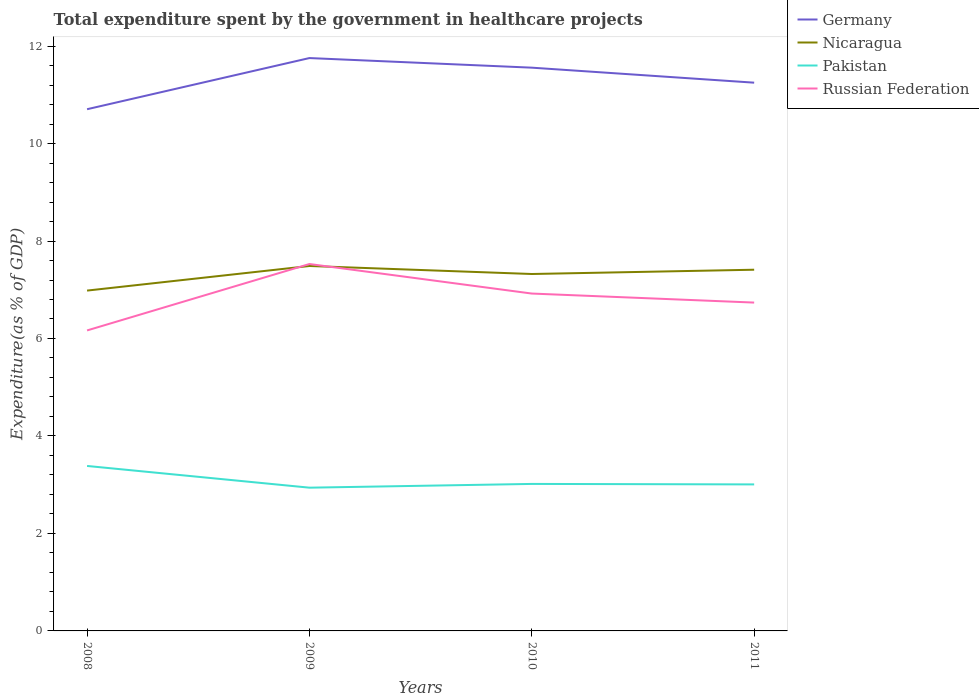Across all years, what is the maximum total expenditure spent by the government in healthcare projects in Germany?
Offer a very short reply. 10.7. What is the total total expenditure spent by the government in healthcare projects in Russian Federation in the graph?
Make the answer very short. -0.57. What is the difference between the highest and the second highest total expenditure spent by the government in healthcare projects in Russian Federation?
Your answer should be very brief. 1.36. How many years are there in the graph?
Ensure brevity in your answer.  4. Does the graph contain any zero values?
Make the answer very short. No. How are the legend labels stacked?
Make the answer very short. Vertical. What is the title of the graph?
Provide a short and direct response. Total expenditure spent by the government in healthcare projects. What is the label or title of the Y-axis?
Your answer should be very brief. Expenditure(as % of GDP). What is the Expenditure(as % of GDP) in Germany in 2008?
Offer a terse response. 10.7. What is the Expenditure(as % of GDP) in Nicaragua in 2008?
Offer a very short reply. 6.98. What is the Expenditure(as % of GDP) of Pakistan in 2008?
Your response must be concise. 3.38. What is the Expenditure(as % of GDP) of Russian Federation in 2008?
Provide a short and direct response. 6.17. What is the Expenditure(as % of GDP) in Germany in 2009?
Ensure brevity in your answer.  11.75. What is the Expenditure(as % of GDP) of Nicaragua in 2009?
Ensure brevity in your answer.  7.49. What is the Expenditure(as % of GDP) of Pakistan in 2009?
Make the answer very short. 2.94. What is the Expenditure(as % of GDP) in Russian Federation in 2009?
Your answer should be very brief. 7.53. What is the Expenditure(as % of GDP) of Germany in 2010?
Ensure brevity in your answer.  11.56. What is the Expenditure(as % of GDP) of Nicaragua in 2010?
Offer a very short reply. 7.32. What is the Expenditure(as % of GDP) of Pakistan in 2010?
Give a very brief answer. 3.02. What is the Expenditure(as % of GDP) of Russian Federation in 2010?
Your answer should be very brief. 6.92. What is the Expenditure(as % of GDP) of Germany in 2011?
Provide a succinct answer. 11.25. What is the Expenditure(as % of GDP) in Nicaragua in 2011?
Offer a very short reply. 7.41. What is the Expenditure(as % of GDP) of Pakistan in 2011?
Give a very brief answer. 3.01. What is the Expenditure(as % of GDP) of Russian Federation in 2011?
Offer a terse response. 6.74. Across all years, what is the maximum Expenditure(as % of GDP) in Germany?
Your response must be concise. 11.75. Across all years, what is the maximum Expenditure(as % of GDP) in Nicaragua?
Give a very brief answer. 7.49. Across all years, what is the maximum Expenditure(as % of GDP) of Pakistan?
Your answer should be very brief. 3.38. Across all years, what is the maximum Expenditure(as % of GDP) of Russian Federation?
Offer a very short reply. 7.53. Across all years, what is the minimum Expenditure(as % of GDP) of Germany?
Your response must be concise. 10.7. Across all years, what is the minimum Expenditure(as % of GDP) of Nicaragua?
Provide a succinct answer. 6.98. Across all years, what is the minimum Expenditure(as % of GDP) in Pakistan?
Give a very brief answer. 2.94. Across all years, what is the minimum Expenditure(as % of GDP) of Russian Federation?
Your answer should be very brief. 6.17. What is the total Expenditure(as % of GDP) of Germany in the graph?
Your answer should be compact. 45.26. What is the total Expenditure(as % of GDP) of Nicaragua in the graph?
Provide a succinct answer. 29.2. What is the total Expenditure(as % of GDP) of Pakistan in the graph?
Your answer should be compact. 12.35. What is the total Expenditure(as % of GDP) of Russian Federation in the graph?
Keep it short and to the point. 27.35. What is the difference between the Expenditure(as % of GDP) of Germany in 2008 and that in 2009?
Provide a short and direct response. -1.05. What is the difference between the Expenditure(as % of GDP) in Nicaragua in 2008 and that in 2009?
Provide a succinct answer. -0.5. What is the difference between the Expenditure(as % of GDP) in Pakistan in 2008 and that in 2009?
Offer a very short reply. 0.45. What is the difference between the Expenditure(as % of GDP) of Russian Federation in 2008 and that in 2009?
Give a very brief answer. -1.36. What is the difference between the Expenditure(as % of GDP) in Germany in 2008 and that in 2010?
Your answer should be very brief. -0.85. What is the difference between the Expenditure(as % of GDP) of Nicaragua in 2008 and that in 2010?
Offer a terse response. -0.34. What is the difference between the Expenditure(as % of GDP) in Pakistan in 2008 and that in 2010?
Offer a terse response. 0.37. What is the difference between the Expenditure(as % of GDP) of Russian Federation in 2008 and that in 2010?
Make the answer very short. -0.76. What is the difference between the Expenditure(as % of GDP) of Germany in 2008 and that in 2011?
Your answer should be very brief. -0.54. What is the difference between the Expenditure(as % of GDP) in Nicaragua in 2008 and that in 2011?
Your response must be concise. -0.43. What is the difference between the Expenditure(as % of GDP) of Pakistan in 2008 and that in 2011?
Ensure brevity in your answer.  0.38. What is the difference between the Expenditure(as % of GDP) in Russian Federation in 2008 and that in 2011?
Provide a succinct answer. -0.57. What is the difference between the Expenditure(as % of GDP) of Germany in 2009 and that in 2010?
Give a very brief answer. 0.2. What is the difference between the Expenditure(as % of GDP) of Nicaragua in 2009 and that in 2010?
Your response must be concise. 0.16. What is the difference between the Expenditure(as % of GDP) in Pakistan in 2009 and that in 2010?
Your response must be concise. -0.08. What is the difference between the Expenditure(as % of GDP) in Russian Federation in 2009 and that in 2010?
Your response must be concise. 0.61. What is the difference between the Expenditure(as % of GDP) of Germany in 2009 and that in 2011?
Your response must be concise. 0.51. What is the difference between the Expenditure(as % of GDP) of Nicaragua in 2009 and that in 2011?
Provide a short and direct response. 0.08. What is the difference between the Expenditure(as % of GDP) of Pakistan in 2009 and that in 2011?
Make the answer very short. -0.07. What is the difference between the Expenditure(as % of GDP) in Russian Federation in 2009 and that in 2011?
Provide a short and direct response. 0.79. What is the difference between the Expenditure(as % of GDP) of Germany in 2010 and that in 2011?
Offer a very short reply. 0.31. What is the difference between the Expenditure(as % of GDP) in Nicaragua in 2010 and that in 2011?
Offer a very short reply. -0.09. What is the difference between the Expenditure(as % of GDP) in Pakistan in 2010 and that in 2011?
Ensure brevity in your answer.  0.01. What is the difference between the Expenditure(as % of GDP) of Russian Federation in 2010 and that in 2011?
Your response must be concise. 0.19. What is the difference between the Expenditure(as % of GDP) in Germany in 2008 and the Expenditure(as % of GDP) in Nicaragua in 2009?
Make the answer very short. 3.22. What is the difference between the Expenditure(as % of GDP) in Germany in 2008 and the Expenditure(as % of GDP) in Pakistan in 2009?
Give a very brief answer. 7.76. What is the difference between the Expenditure(as % of GDP) in Germany in 2008 and the Expenditure(as % of GDP) in Russian Federation in 2009?
Make the answer very short. 3.18. What is the difference between the Expenditure(as % of GDP) of Nicaragua in 2008 and the Expenditure(as % of GDP) of Pakistan in 2009?
Make the answer very short. 4.04. What is the difference between the Expenditure(as % of GDP) of Nicaragua in 2008 and the Expenditure(as % of GDP) of Russian Federation in 2009?
Your response must be concise. -0.55. What is the difference between the Expenditure(as % of GDP) of Pakistan in 2008 and the Expenditure(as % of GDP) of Russian Federation in 2009?
Provide a short and direct response. -4.14. What is the difference between the Expenditure(as % of GDP) of Germany in 2008 and the Expenditure(as % of GDP) of Nicaragua in 2010?
Your answer should be compact. 3.38. What is the difference between the Expenditure(as % of GDP) of Germany in 2008 and the Expenditure(as % of GDP) of Pakistan in 2010?
Offer a very short reply. 7.69. What is the difference between the Expenditure(as % of GDP) of Germany in 2008 and the Expenditure(as % of GDP) of Russian Federation in 2010?
Your answer should be compact. 3.78. What is the difference between the Expenditure(as % of GDP) of Nicaragua in 2008 and the Expenditure(as % of GDP) of Pakistan in 2010?
Give a very brief answer. 3.97. What is the difference between the Expenditure(as % of GDP) in Nicaragua in 2008 and the Expenditure(as % of GDP) in Russian Federation in 2010?
Provide a short and direct response. 0.06. What is the difference between the Expenditure(as % of GDP) of Pakistan in 2008 and the Expenditure(as % of GDP) of Russian Federation in 2010?
Your response must be concise. -3.54. What is the difference between the Expenditure(as % of GDP) in Germany in 2008 and the Expenditure(as % of GDP) in Nicaragua in 2011?
Your answer should be very brief. 3.29. What is the difference between the Expenditure(as % of GDP) in Germany in 2008 and the Expenditure(as % of GDP) in Pakistan in 2011?
Give a very brief answer. 7.7. What is the difference between the Expenditure(as % of GDP) of Germany in 2008 and the Expenditure(as % of GDP) of Russian Federation in 2011?
Give a very brief answer. 3.97. What is the difference between the Expenditure(as % of GDP) of Nicaragua in 2008 and the Expenditure(as % of GDP) of Pakistan in 2011?
Keep it short and to the point. 3.98. What is the difference between the Expenditure(as % of GDP) in Nicaragua in 2008 and the Expenditure(as % of GDP) in Russian Federation in 2011?
Make the answer very short. 0.25. What is the difference between the Expenditure(as % of GDP) of Pakistan in 2008 and the Expenditure(as % of GDP) of Russian Federation in 2011?
Give a very brief answer. -3.35. What is the difference between the Expenditure(as % of GDP) of Germany in 2009 and the Expenditure(as % of GDP) of Nicaragua in 2010?
Provide a short and direct response. 4.43. What is the difference between the Expenditure(as % of GDP) in Germany in 2009 and the Expenditure(as % of GDP) in Pakistan in 2010?
Provide a short and direct response. 8.74. What is the difference between the Expenditure(as % of GDP) in Germany in 2009 and the Expenditure(as % of GDP) in Russian Federation in 2010?
Make the answer very short. 4.83. What is the difference between the Expenditure(as % of GDP) in Nicaragua in 2009 and the Expenditure(as % of GDP) in Pakistan in 2010?
Provide a short and direct response. 4.47. What is the difference between the Expenditure(as % of GDP) in Nicaragua in 2009 and the Expenditure(as % of GDP) in Russian Federation in 2010?
Your answer should be very brief. 0.57. What is the difference between the Expenditure(as % of GDP) of Pakistan in 2009 and the Expenditure(as % of GDP) of Russian Federation in 2010?
Keep it short and to the point. -3.98. What is the difference between the Expenditure(as % of GDP) in Germany in 2009 and the Expenditure(as % of GDP) in Nicaragua in 2011?
Give a very brief answer. 4.34. What is the difference between the Expenditure(as % of GDP) in Germany in 2009 and the Expenditure(as % of GDP) in Pakistan in 2011?
Give a very brief answer. 8.75. What is the difference between the Expenditure(as % of GDP) in Germany in 2009 and the Expenditure(as % of GDP) in Russian Federation in 2011?
Keep it short and to the point. 5.02. What is the difference between the Expenditure(as % of GDP) of Nicaragua in 2009 and the Expenditure(as % of GDP) of Pakistan in 2011?
Your response must be concise. 4.48. What is the difference between the Expenditure(as % of GDP) in Nicaragua in 2009 and the Expenditure(as % of GDP) in Russian Federation in 2011?
Your answer should be very brief. 0.75. What is the difference between the Expenditure(as % of GDP) in Pakistan in 2009 and the Expenditure(as % of GDP) in Russian Federation in 2011?
Ensure brevity in your answer.  -3.8. What is the difference between the Expenditure(as % of GDP) in Germany in 2010 and the Expenditure(as % of GDP) in Nicaragua in 2011?
Provide a short and direct response. 4.15. What is the difference between the Expenditure(as % of GDP) of Germany in 2010 and the Expenditure(as % of GDP) of Pakistan in 2011?
Keep it short and to the point. 8.55. What is the difference between the Expenditure(as % of GDP) of Germany in 2010 and the Expenditure(as % of GDP) of Russian Federation in 2011?
Give a very brief answer. 4.82. What is the difference between the Expenditure(as % of GDP) of Nicaragua in 2010 and the Expenditure(as % of GDP) of Pakistan in 2011?
Provide a short and direct response. 4.32. What is the difference between the Expenditure(as % of GDP) of Nicaragua in 2010 and the Expenditure(as % of GDP) of Russian Federation in 2011?
Keep it short and to the point. 0.59. What is the difference between the Expenditure(as % of GDP) in Pakistan in 2010 and the Expenditure(as % of GDP) in Russian Federation in 2011?
Your answer should be very brief. -3.72. What is the average Expenditure(as % of GDP) of Germany per year?
Give a very brief answer. 11.32. What is the average Expenditure(as % of GDP) in Nicaragua per year?
Your answer should be very brief. 7.3. What is the average Expenditure(as % of GDP) of Pakistan per year?
Keep it short and to the point. 3.09. What is the average Expenditure(as % of GDP) of Russian Federation per year?
Make the answer very short. 6.84. In the year 2008, what is the difference between the Expenditure(as % of GDP) of Germany and Expenditure(as % of GDP) of Nicaragua?
Provide a succinct answer. 3.72. In the year 2008, what is the difference between the Expenditure(as % of GDP) of Germany and Expenditure(as % of GDP) of Pakistan?
Provide a short and direct response. 7.32. In the year 2008, what is the difference between the Expenditure(as % of GDP) of Germany and Expenditure(as % of GDP) of Russian Federation?
Your answer should be very brief. 4.54. In the year 2008, what is the difference between the Expenditure(as % of GDP) of Nicaragua and Expenditure(as % of GDP) of Pakistan?
Give a very brief answer. 3.6. In the year 2008, what is the difference between the Expenditure(as % of GDP) of Nicaragua and Expenditure(as % of GDP) of Russian Federation?
Make the answer very short. 0.82. In the year 2008, what is the difference between the Expenditure(as % of GDP) of Pakistan and Expenditure(as % of GDP) of Russian Federation?
Your answer should be compact. -2.78. In the year 2009, what is the difference between the Expenditure(as % of GDP) of Germany and Expenditure(as % of GDP) of Nicaragua?
Your response must be concise. 4.27. In the year 2009, what is the difference between the Expenditure(as % of GDP) in Germany and Expenditure(as % of GDP) in Pakistan?
Provide a short and direct response. 8.81. In the year 2009, what is the difference between the Expenditure(as % of GDP) in Germany and Expenditure(as % of GDP) in Russian Federation?
Your answer should be compact. 4.23. In the year 2009, what is the difference between the Expenditure(as % of GDP) of Nicaragua and Expenditure(as % of GDP) of Pakistan?
Provide a succinct answer. 4.55. In the year 2009, what is the difference between the Expenditure(as % of GDP) of Nicaragua and Expenditure(as % of GDP) of Russian Federation?
Keep it short and to the point. -0.04. In the year 2009, what is the difference between the Expenditure(as % of GDP) in Pakistan and Expenditure(as % of GDP) in Russian Federation?
Provide a succinct answer. -4.59. In the year 2010, what is the difference between the Expenditure(as % of GDP) of Germany and Expenditure(as % of GDP) of Nicaragua?
Your answer should be compact. 4.23. In the year 2010, what is the difference between the Expenditure(as % of GDP) of Germany and Expenditure(as % of GDP) of Pakistan?
Provide a short and direct response. 8.54. In the year 2010, what is the difference between the Expenditure(as % of GDP) of Germany and Expenditure(as % of GDP) of Russian Federation?
Give a very brief answer. 4.63. In the year 2010, what is the difference between the Expenditure(as % of GDP) of Nicaragua and Expenditure(as % of GDP) of Pakistan?
Offer a terse response. 4.31. In the year 2010, what is the difference between the Expenditure(as % of GDP) in Nicaragua and Expenditure(as % of GDP) in Russian Federation?
Provide a short and direct response. 0.4. In the year 2010, what is the difference between the Expenditure(as % of GDP) in Pakistan and Expenditure(as % of GDP) in Russian Federation?
Ensure brevity in your answer.  -3.91. In the year 2011, what is the difference between the Expenditure(as % of GDP) in Germany and Expenditure(as % of GDP) in Nicaragua?
Offer a very short reply. 3.84. In the year 2011, what is the difference between the Expenditure(as % of GDP) in Germany and Expenditure(as % of GDP) in Pakistan?
Your response must be concise. 8.24. In the year 2011, what is the difference between the Expenditure(as % of GDP) in Germany and Expenditure(as % of GDP) in Russian Federation?
Your response must be concise. 4.51. In the year 2011, what is the difference between the Expenditure(as % of GDP) in Nicaragua and Expenditure(as % of GDP) in Pakistan?
Your answer should be very brief. 4.4. In the year 2011, what is the difference between the Expenditure(as % of GDP) in Nicaragua and Expenditure(as % of GDP) in Russian Federation?
Provide a succinct answer. 0.67. In the year 2011, what is the difference between the Expenditure(as % of GDP) in Pakistan and Expenditure(as % of GDP) in Russian Federation?
Ensure brevity in your answer.  -3.73. What is the ratio of the Expenditure(as % of GDP) of Germany in 2008 to that in 2009?
Ensure brevity in your answer.  0.91. What is the ratio of the Expenditure(as % of GDP) in Nicaragua in 2008 to that in 2009?
Ensure brevity in your answer.  0.93. What is the ratio of the Expenditure(as % of GDP) of Pakistan in 2008 to that in 2009?
Your response must be concise. 1.15. What is the ratio of the Expenditure(as % of GDP) of Russian Federation in 2008 to that in 2009?
Give a very brief answer. 0.82. What is the ratio of the Expenditure(as % of GDP) of Germany in 2008 to that in 2010?
Provide a succinct answer. 0.93. What is the ratio of the Expenditure(as % of GDP) of Nicaragua in 2008 to that in 2010?
Your answer should be very brief. 0.95. What is the ratio of the Expenditure(as % of GDP) of Pakistan in 2008 to that in 2010?
Your response must be concise. 1.12. What is the ratio of the Expenditure(as % of GDP) of Russian Federation in 2008 to that in 2010?
Keep it short and to the point. 0.89. What is the ratio of the Expenditure(as % of GDP) in Germany in 2008 to that in 2011?
Your response must be concise. 0.95. What is the ratio of the Expenditure(as % of GDP) in Nicaragua in 2008 to that in 2011?
Provide a short and direct response. 0.94. What is the ratio of the Expenditure(as % of GDP) in Pakistan in 2008 to that in 2011?
Your response must be concise. 1.13. What is the ratio of the Expenditure(as % of GDP) of Russian Federation in 2008 to that in 2011?
Give a very brief answer. 0.92. What is the ratio of the Expenditure(as % of GDP) of Germany in 2009 to that in 2010?
Your answer should be very brief. 1.02. What is the ratio of the Expenditure(as % of GDP) in Nicaragua in 2009 to that in 2010?
Provide a succinct answer. 1.02. What is the ratio of the Expenditure(as % of GDP) in Pakistan in 2009 to that in 2010?
Offer a very short reply. 0.97. What is the ratio of the Expenditure(as % of GDP) of Russian Federation in 2009 to that in 2010?
Keep it short and to the point. 1.09. What is the ratio of the Expenditure(as % of GDP) of Germany in 2009 to that in 2011?
Your answer should be very brief. 1.04. What is the ratio of the Expenditure(as % of GDP) of Nicaragua in 2009 to that in 2011?
Offer a terse response. 1.01. What is the ratio of the Expenditure(as % of GDP) of Pakistan in 2009 to that in 2011?
Your answer should be compact. 0.98. What is the ratio of the Expenditure(as % of GDP) in Russian Federation in 2009 to that in 2011?
Provide a succinct answer. 1.12. What is the ratio of the Expenditure(as % of GDP) of Germany in 2010 to that in 2011?
Offer a very short reply. 1.03. What is the ratio of the Expenditure(as % of GDP) of Pakistan in 2010 to that in 2011?
Keep it short and to the point. 1. What is the ratio of the Expenditure(as % of GDP) in Russian Federation in 2010 to that in 2011?
Make the answer very short. 1.03. What is the difference between the highest and the second highest Expenditure(as % of GDP) of Germany?
Your answer should be compact. 0.2. What is the difference between the highest and the second highest Expenditure(as % of GDP) in Nicaragua?
Ensure brevity in your answer.  0.08. What is the difference between the highest and the second highest Expenditure(as % of GDP) of Pakistan?
Your answer should be very brief. 0.37. What is the difference between the highest and the second highest Expenditure(as % of GDP) in Russian Federation?
Provide a short and direct response. 0.61. What is the difference between the highest and the lowest Expenditure(as % of GDP) of Germany?
Your answer should be very brief. 1.05. What is the difference between the highest and the lowest Expenditure(as % of GDP) in Nicaragua?
Offer a very short reply. 0.5. What is the difference between the highest and the lowest Expenditure(as % of GDP) in Pakistan?
Ensure brevity in your answer.  0.45. What is the difference between the highest and the lowest Expenditure(as % of GDP) of Russian Federation?
Your answer should be compact. 1.36. 